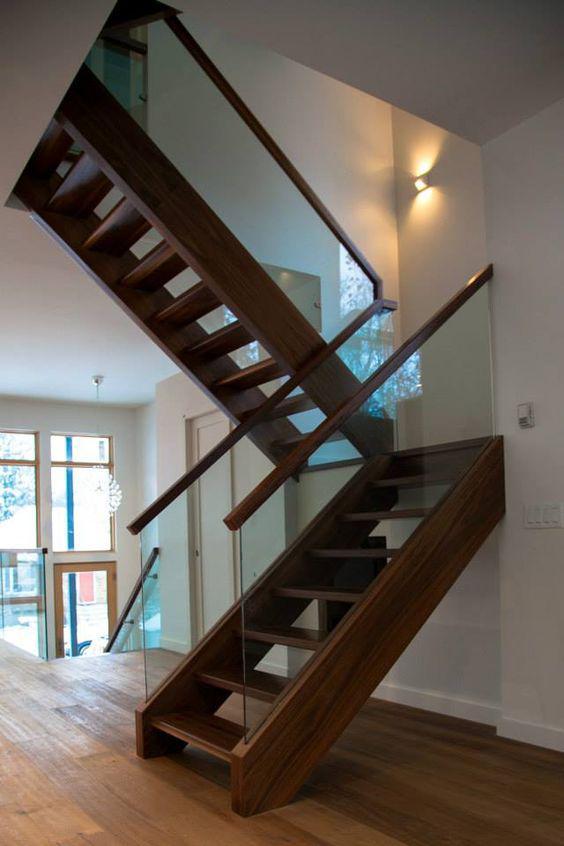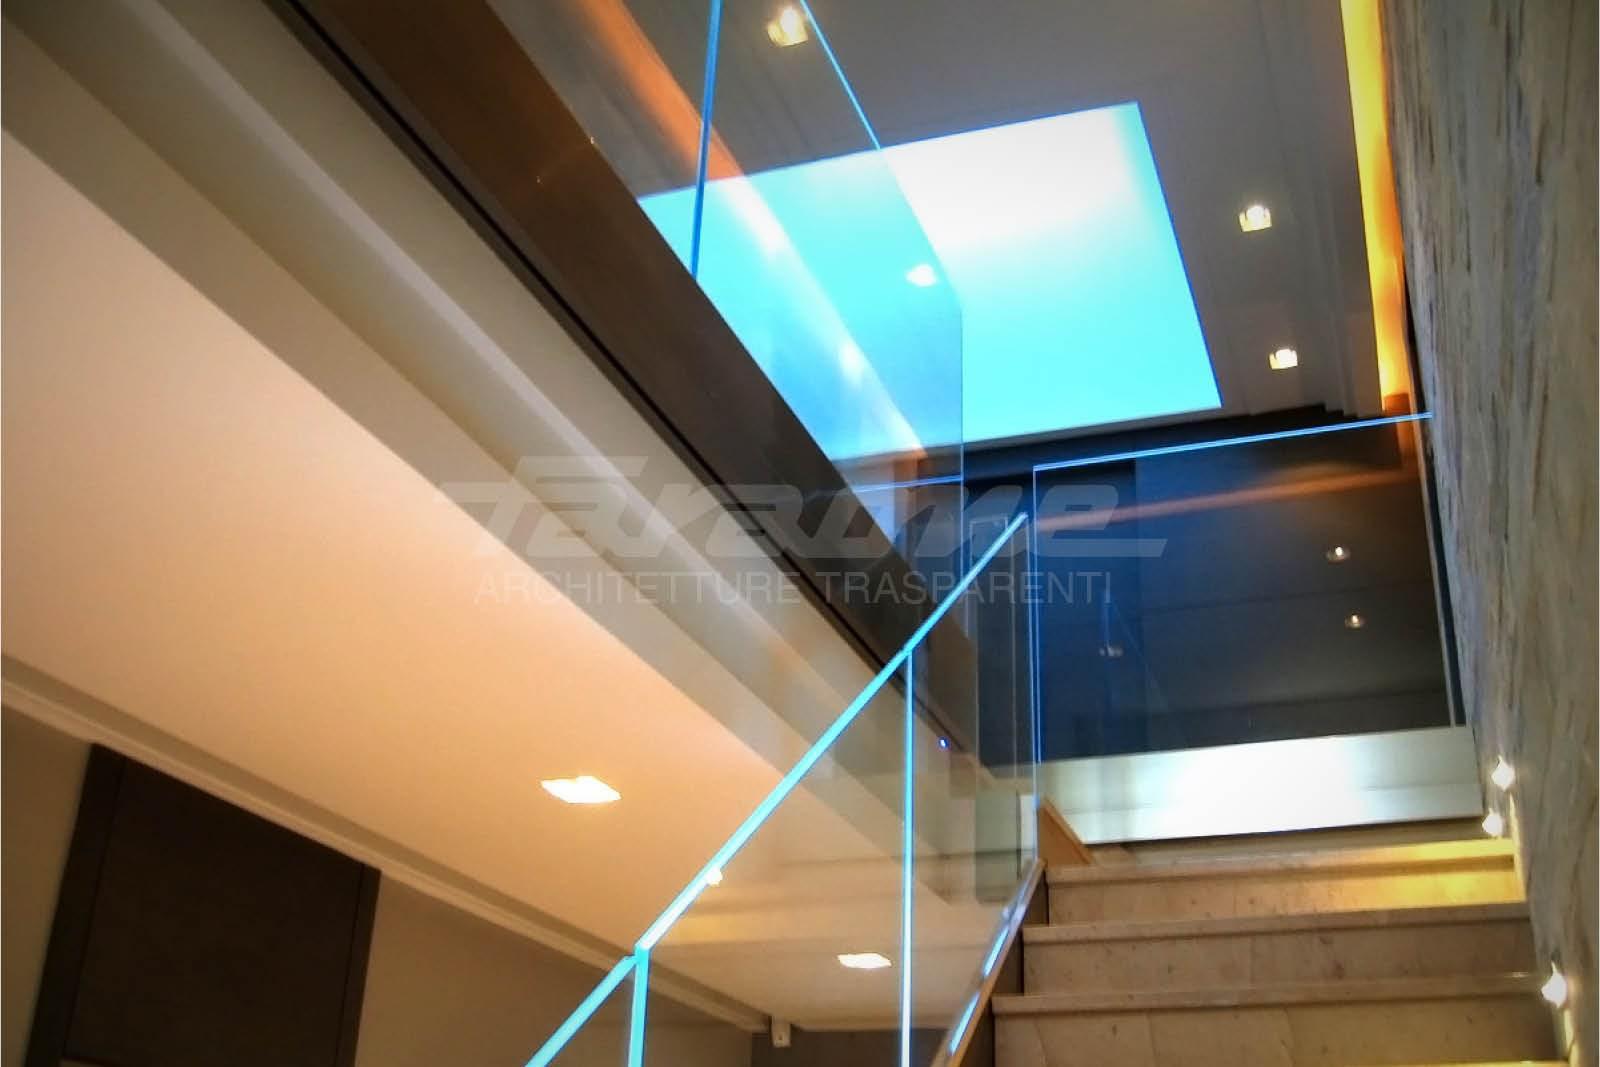The first image is the image on the left, the second image is the image on the right. Given the left and right images, does the statement "An image shows a stairwell enclosed by glass panels without a top rail or hinges." hold true? Answer yes or no. Yes. The first image is the image on the left, the second image is the image on the right. Given the left and right images, does the statement "Both images show an indoor staircase that has glass siding instead of banisters." hold true? Answer yes or no. Yes. 